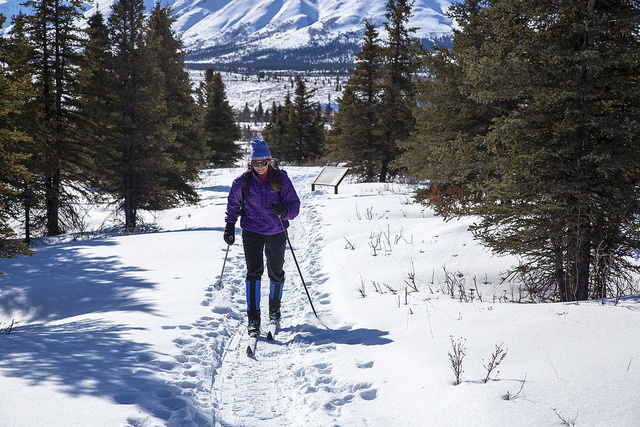Describe the objects in this image and their specific colors. I can see people in white, black, navy, and lightgray tones and skis in white, lightgray, black, gray, and darkgray tones in this image. 